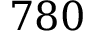<formula> <loc_0><loc_0><loc_500><loc_500>7 8 0</formula> 